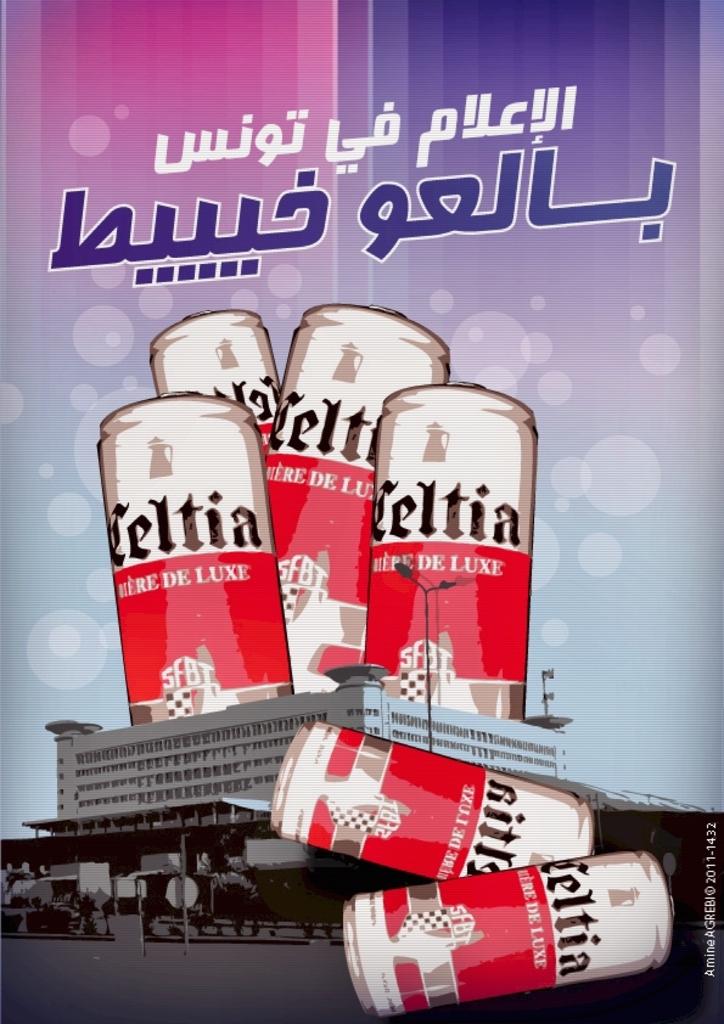What brand is in the ad?
Provide a succinct answer. Celtia. What beverage is in these cans?
Give a very brief answer. Celtia. 